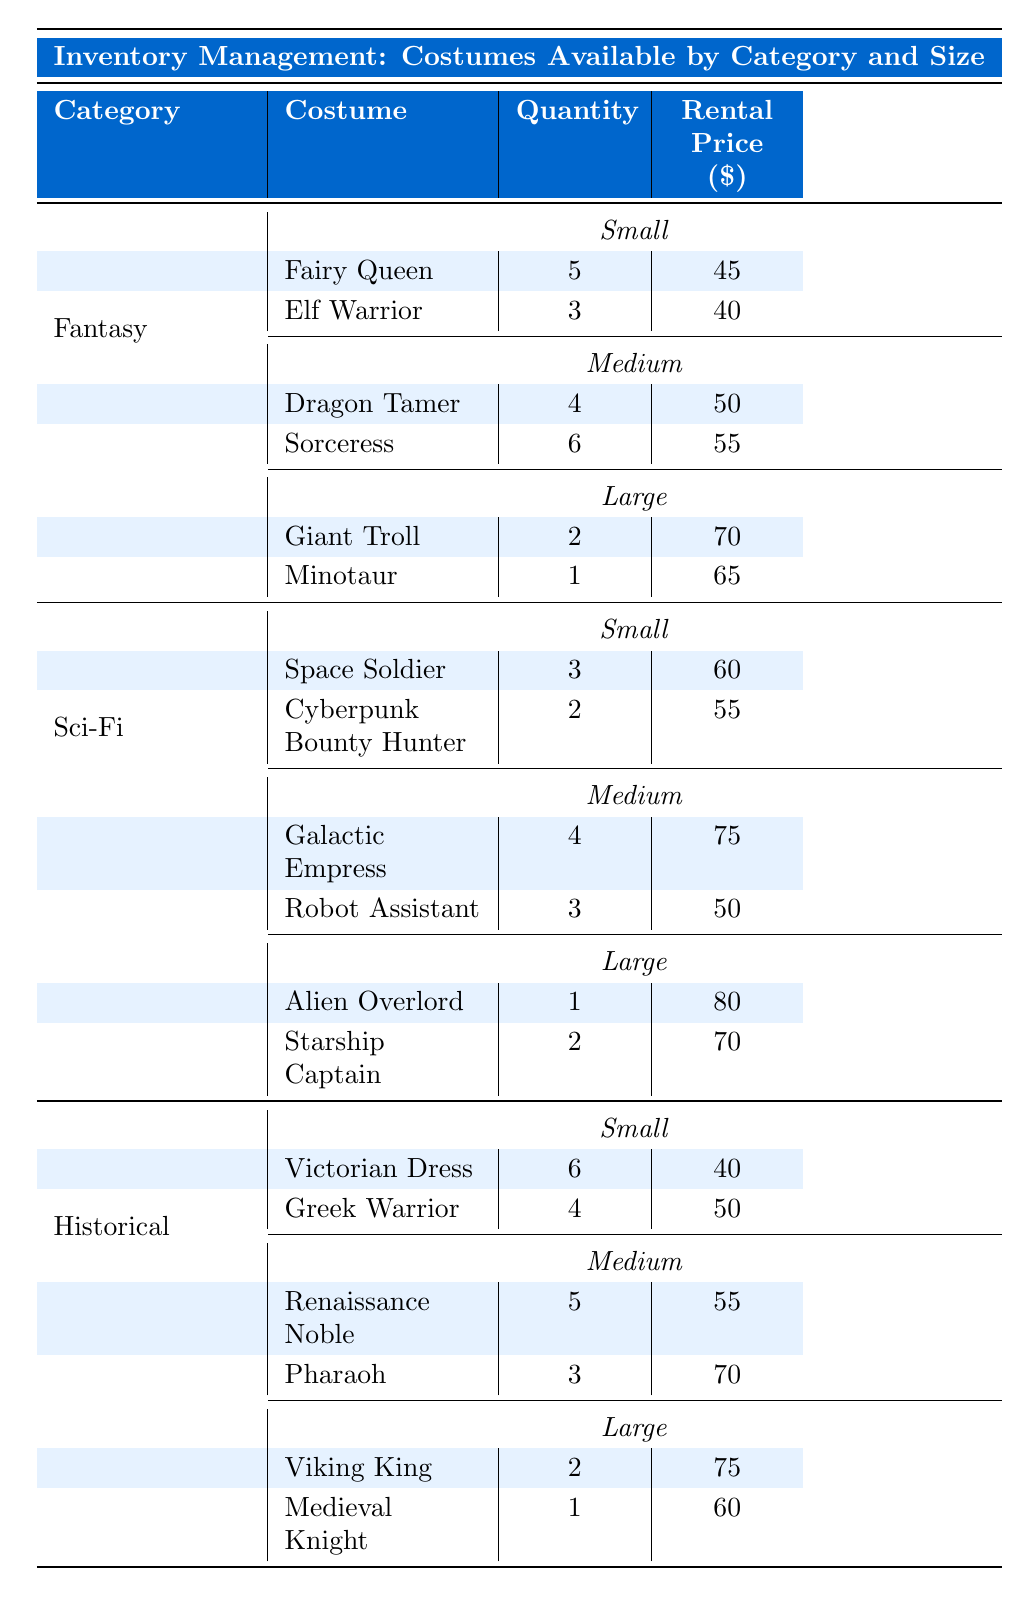What is the rental price for the "Giant Troll"? The table lists the "Giant Troll" costume under the Fantasy category in the Large size section, and its rental price is shown as $70.
Answer: $70 How many "Victorian Dress" costumes are available? The "Victorian Dress" costume is found in the Historical category under the Small size section, where it shows a quantity of 6.
Answer: 6 Which is the most expensive costume in the inventory? To find the most expensive costume, I compare the rental prices listed for each costume. The "Alien Overlord" has the highest price at $80.
Answer: Alien Overlord What is the total number of costumes available in the Sci-Fi category? For the Sci-Fi category, I add the quantities of the costumes listed in Small, Medium, and Large sizes: (3 + 2) + (4 + 3) + (1 + 2) = 15.
Answer: 15 How many "Medium" sized costumes are in the Fantasy category? The table lists two Medium costumes under the Fantasy category: "Dragon Tamer" (quantity 4) and "Sorceress" (quantity 6). Adding these gives 4 + 6 = 10.
Answer: 10 Is there a "Cyberpunk Bounty Hunter" costume available in Large size? The table shows the "Cyberpunk Bounty Hunter" costume only in the Small size section of the Sci-Fi category, indicating it is not available in Large size.
Answer: No What is the average rental price of Large costumes across all categories? For Large costumes, I find the prices: $70 (Giant Troll), $65 (Minotaur), $80 (Alien Overlord), $70 (Starship Captain), $75 (Viking King), and $60 (Medieval Knight). The average is calculated as (70 + 65 + 80 + 70 + 75 + 60) / 6 = 70.
Answer: 70 How many costumes in the Historical category have a rental price of more than $70? By examining the Historical category, the "Pharaoh" ($70), "Viking King" ($75), and "Medieval Knight" ($60) are noted. Only "Viking King" has a price over $70.
Answer: 1 If a customer wants to rent three "Small" size costumes from different categories, how many would be left in total? Starting with the Small sizes, total available is 5 (Fairy Queen) + 3 (Elf Warrior) + 3 (Space Soldier) + 2 (Cyberpunk Bounty Hunter) + 6 (Victorian Dress) + 4 (Greek Warrior) = 23. Renting three would leave 20 costumes remaining.
Answer: 20 Are there more costumes available in Small size than in Medium size across all categories? By adding the quantities for Small (5 + 3 + 3 + 2 + 6 + 4 = 23) and Medium (4 + 6 + 4 + 3 + 5 + 3 = 25), we see Medium has more at 25.
Answer: No 